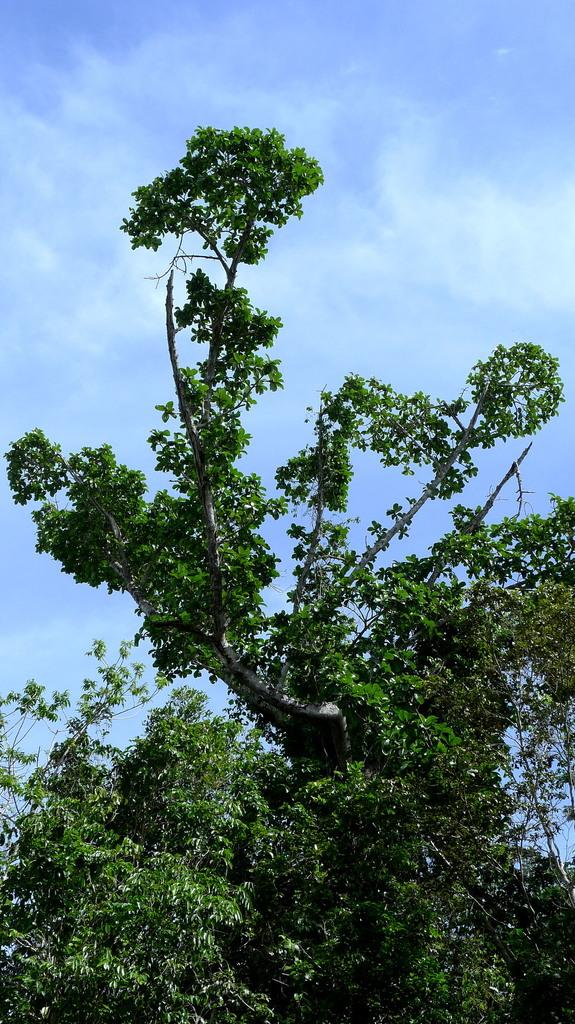What is the main object in the image? There is a tree in the image. What can be seen behind the tree? The sky is visible behind the tree. How would you describe the sky in the image? The sky is clear in the image. How many sisters are sitting under the tree in the image? There are no sisters present in the image; it only features a tree and the sky. 